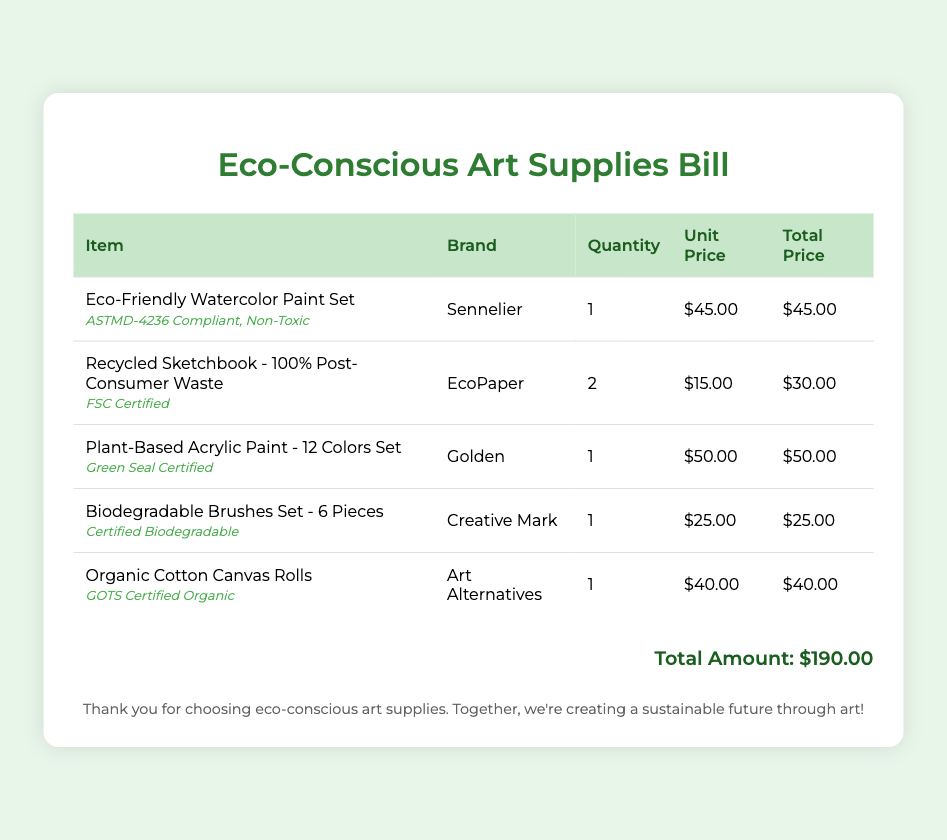what is the total amount of the bill? The total amount is at the bottom of the bill, representing the sum of all purchases listed.
Answer: $190.00 how many Eco-Friendly Watercolor Paint Sets were purchased? The quantity of Eco-Friendly Watercolor Paint Sets is found in the respective row under the Quantity column.
Answer: 1 which brand makes the Plant-Based Acrylic Paint? The brand is listed in the Brand column for the corresponding product row.
Answer: Golden what certification does the Organic Cotton Canvas Rolls have? The certification is mentioned in the product description for Organic Cotton Canvas Rolls.
Answer: GOTS Certified Organic how much does the Recycled Sketchbook cost per unit? The unit price is shown under the Unit Price column for the Recycled Sketchbook.
Answer: $15.00 which product is certified biodegradable? The certification is explicitly stated in the product description under the relevant row.
Answer: Biodegradable Brushes Set what is the total number of products listed on the bill? The total number of products can be calculated by counting the rows in the table that list individual items.
Answer: 5 who is the supplier of the biodegradable brushes? The supplier can be identified in the Brand column for the corresponding product entry.
Answer: Creative Mark how many different products were purchased in total? The different products are counted based on the entries in the Items column of the table.
Answer: 5 